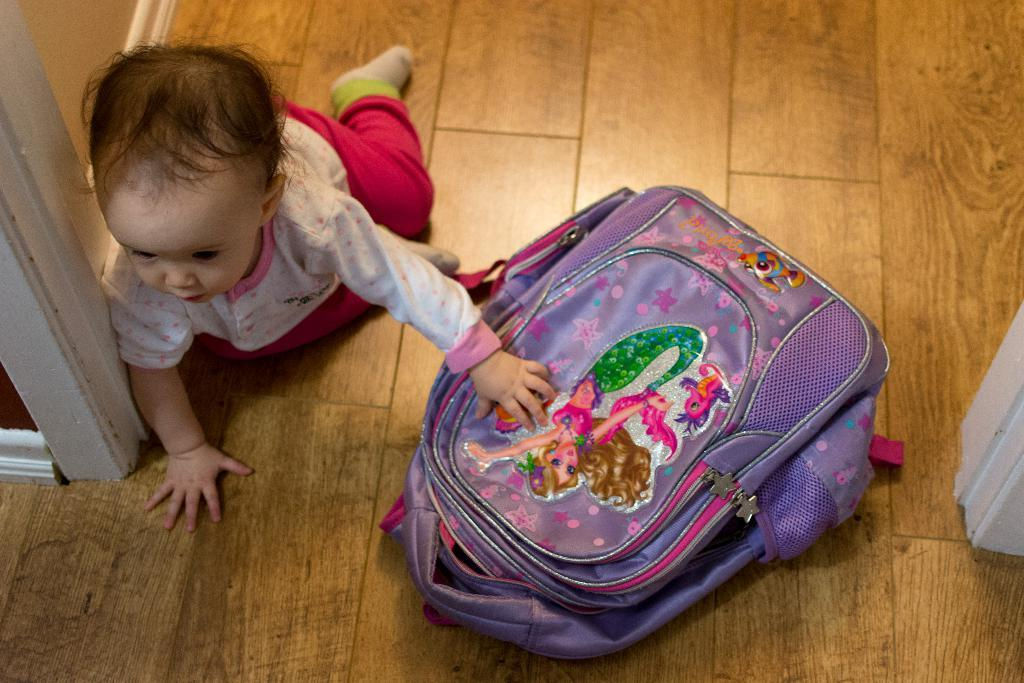What is the main subject of the image? The main subject of the image is a kid. What object can be seen placed on the floor in the image? There is a bag placed on the floor in the image. What type of plantation can be seen in the background of the image? There is no plantation present in the image. How many cows are visible in the image? There are no cows visible in the image. 